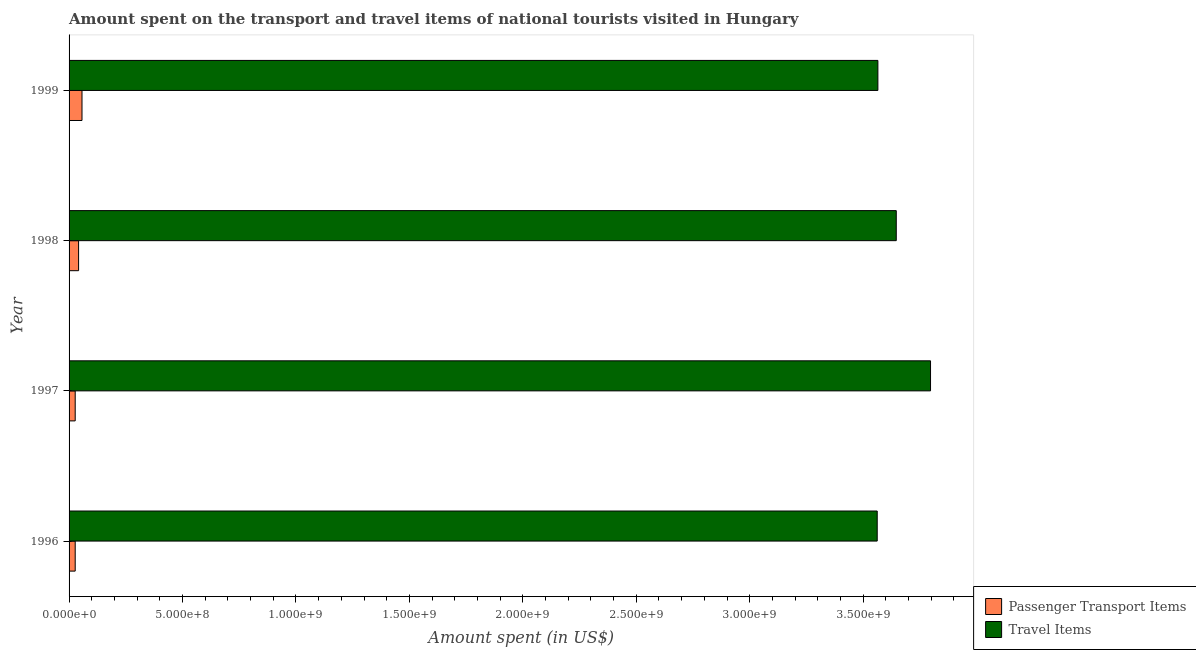How many different coloured bars are there?
Offer a terse response. 2. What is the label of the 4th group of bars from the top?
Give a very brief answer. 1996. What is the amount spent in travel items in 1996?
Give a very brief answer. 3.56e+09. Across all years, what is the maximum amount spent in travel items?
Your response must be concise. 3.80e+09. Across all years, what is the minimum amount spent in travel items?
Provide a short and direct response. 3.56e+09. In which year was the amount spent on passenger transport items maximum?
Give a very brief answer. 1999. In which year was the amount spent on passenger transport items minimum?
Give a very brief answer. 1996. What is the total amount spent on passenger transport items in the graph?
Make the answer very short. 1.53e+08. What is the difference between the amount spent on passenger transport items in 1996 and that in 1997?
Offer a terse response. 0. What is the difference between the amount spent on passenger transport items in 1999 and the amount spent in travel items in 1998?
Keep it short and to the point. -3.59e+09. What is the average amount spent in travel items per year?
Ensure brevity in your answer.  3.64e+09. In the year 1998, what is the difference between the amount spent in travel items and amount spent on passenger transport items?
Provide a short and direct response. 3.60e+09. What is the ratio of the amount spent on passenger transport items in 1998 to that in 1999?
Provide a short and direct response. 0.74. Is the difference between the amount spent in travel items in 1996 and 1998 greater than the difference between the amount spent on passenger transport items in 1996 and 1998?
Provide a succinct answer. No. What is the difference between the highest and the second highest amount spent on passenger transport items?
Give a very brief answer. 1.50e+07. What is the difference between the highest and the lowest amount spent in travel items?
Offer a terse response. 2.35e+08. Is the sum of the amount spent in travel items in 1996 and 1998 greater than the maximum amount spent on passenger transport items across all years?
Your answer should be compact. Yes. What does the 2nd bar from the top in 1998 represents?
Give a very brief answer. Passenger Transport Items. What does the 1st bar from the bottom in 1998 represents?
Your response must be concise. Passenger Transport Items. How many bars are there?
Give a very brief answer. 8. How many years are there in the graph?
Your answer should be very brief. 4. What is the difference between two consecutive major ticks on the X-axis?
Offer a very short reply. 5.00e+08. Are the values on the major ticks of X-axis written in scientific E-notation?
Offer a very short reply. Yes. Does the graph contain any zero values?
Provide a short and direct response. No. How many legend labels are there?
Offer a very short reply. 2. What is the title of the graph?
Give a very brief answer. Amount spent on the transport and travel items of national tourists visited in Hungary. Does "Central government" appear as one of the legend labels in the graph?
Ensure brevity in your answer.  No. What is the label or title of the X-axis?
Make the answer very short. Amount spent (in US$). What is the Amount spent (in US$) in Passenger Transport Items in 1996?
Offer a terse response. 2.70e+07. What is the Amount spent (in US$) in Travel Items in 1996?
Provide a short and direct response. 3.56e+09. What is the Amount spent (in US$) of Passenger Transport Items in 1997?
Offer a terse response. 2.70e+07. What is the Amount spent (in US$) in Travel Items in 1997?
Keep it short and to the point. 3.80e+09. What is the Amount spent (in US$) in Passenger Transport Items in 1998?
Keep it short and to the point. 4.20e+07. What is the Amount spent (in US$) in Travel Items in 1998?
Offer a terse response. 3.65e+09. What is the Amount spent (in US$) of Passenger Transport Items in 1999?
Provide a succinct answer. 5.70e+07. What is the Amount spent (in US$) in Travel Items in 1999?
Provide a succinct answer. 3.56e+09. Across all years, what is the maximum Amount spent (in US$) of Passenger Transport Items?
Your answer should be compact. 5.70e+07. Across all years, what is the maximum Amount spent (in US$) in Travel Items?
Your answer should be very brief. 3.80e+09. Across all years, what is the minimum Amount spent (in US$) of Passenger Transport Items?
Provide a succinct answer. 2.70e+07. Across all years, what is the minimum Amount spent (in US$) in Travel Items?
Offer a terse response. 3.56e+09. What is the total Amount spent (in US$) of Passenger Transport Items in the graph?
Your answer should be compact. 1.53e+08. What is the total Amount spent (in US$) of Travel Items in the graph?
Keep it short and to the point. 1.46e+1. What is the difference between the Amount spent (in US$) of Travel Items in 1996 and that in 1997?
Your response must be concise. -2.35e+08. What is the difference between the Amount spent (in US$) in Passenger Transport Items in 1996 and that in 1998?
Offer a very short reply. -1.50e+07. What is the difference between the Amount spent (in US$) of Travel Items in 1996 and that in 1998?
Provide a short and direct response. -8.40e+07. What is the difference between the Amount spent (in US$) of Passenger Transport Items in 1996 and that in 1999?
Your answer should be very brief. -3.00e+07. What is the difference between the Amount spent (in US$) of Passenger Transport Items in 1997 and that in 1998?
Your response must be concise. -1.50e+07. What is the difference between the Amount spent (in US$) in Travel Items in 1997 and that in 1998?
Provide a short and direct response. 1.51e+08. What is the difference between the Amount spent (in US$) of Passenger Transport Items in 1997 and that in 1999?
Provide a succinct answer. -3.00e+07. What is the difference between the Amount spent (in US$) in Travel Items in 1997 and that in 1999?
Provide a short and direct response. 2.32e+08. What is the difference between the Amount spent (in US$) in Passenger Transport Items in 1998 and that in 1999?
Provide a short and direct response. -1.50e+07. What is the difference between the Amount spent (in US$) of Travel Items in 1998 and that in 1999?
Keep it short and to the point. 8.10e+07. What is the difference between the Amount spent (in US$) in Passenger Transport Items in 1996 and the Amount spent (in US$) in Travel Items in 1997?
Ensure brevity in your answer.  -3.77e+09. What is the difference between the Amount spent (in US$) in Passenger Transport Items in 1996 and the Amount spent (in US$) in Travel Items in 1998?
Ensure brevity in your answer.  -3.62e+09. What is the difference between the Amount spent (in US$) of Passenger Transport Items in 1996 and the Amount spent (in US$) of Travel Items in 1999?
Your answer should be very brief. -3.54e+09. What is the difference between the Amount spent (in US$) in Passenger Transport Items in 1997 and the Amount spent (in US$) in Travel Items in 1998?
Keep it short and to the point. -3.62e+09. What is the difference between the Amount spent (in US$) of Passenger Transport Items in 1997 and the Amount spent (in US$) of Travel Items in 1999?
Offer a very short reply. -3.54e+09. What is the difference between the Amount spent (in US$) in Passenger Transport Items in 1998 and the Amount spent (in US$) in Travel Items in 1999?
Provide a succinct answer. -3.52e+09. What is the average Amount spent (in US$) in Passenger Transport Items per year?
Your answer should be very brief. 3.82e+07. What is the average Amount spent (in US$) in Travel Items per year?
Offer a terse response. 3.64e+09. In the year 1996, what is the difference between the Amount spent (in US$) of Passenger Transport Items and Amount spent (in US$) of Travel Items?
Provide a succinct answer. -3.54e+09. In the year 1997, what is the difference between the Amount spent (in US$) of Passenger Transport Items and Amount spent (in US$) of Travel Items?
Keep it short and to the point. -3.77e+09. In the year 1998, what is the difference between the Amount spent (in US$) of Passenger Transport Items and Amount spent (in US$) of Travel Items?
Your answer should be compact. -3.60e+09. In the year 1999, what is the difference between the Amount spent (in US$) in Passenger Transport Items and Amount spent (in US$) in Travel Items?
Your response must be concise. -3.51e+09. What is the ratio of the Amount spent (in US$) in Travel Items in 1996 to that in 1997?
Your response must be concise. 0.94. What is the ratio of the Amount spent (in US$) in Passenger Transport Items in 1996 to that in 1998?
Offer a very short reply. 0.64. What is the ratio of the Amount spent (in US$) in Passenger Transport Items in 1996 to that in 1999?
Provide a succinct answer. 0.47. What is the ratio of the Amount spent (in US$) of Passenger Transport Items in 1997 to that in 1998?
Give a very brief answer. 0.64. What is the ratio of the Amount spent (in US$) in Travel Items in 1997 to that in 1998?
Your response must be concise. 1.04. What is the ratio of the Amount spent (in US$) in Passenger Transport Items in 1997 to that in 1999?
Offer a very short reply. 0.47. What is the ratio of the Amount spent (in US$) of Travel Items in 1997 to that in 1999?
Provide a succinct answer. 1.07. What is the ratio of the Amount spent (in US$) of Passenger Transport Items in 1998 to that in 1999?
Offer a very short reply. 0.74. What is the ratio of the Amount spent (in US$) in Travel Items in 1998 to that in 1999?
Keep it short and to the point. 1.02. What is the difference between the highest and the second highest Amount spent (in US$) of Passenger Transport Items?
Provide a short and direct response. 1.50e+07. What is the difference between the highest and the second highest Amount spent (in US$) in Travel Items?
Your response must be concise. 1.51e+08. What is the difference between the highest and the lowest Amount spent (in US$) in Passenger Transport Items?
Your answer should be very brief. 3.00e+07. What is the difference between the highest and the lowest Amount spent (in US$) in Travel Items?
Make the answer very short. 2.35e+08. 